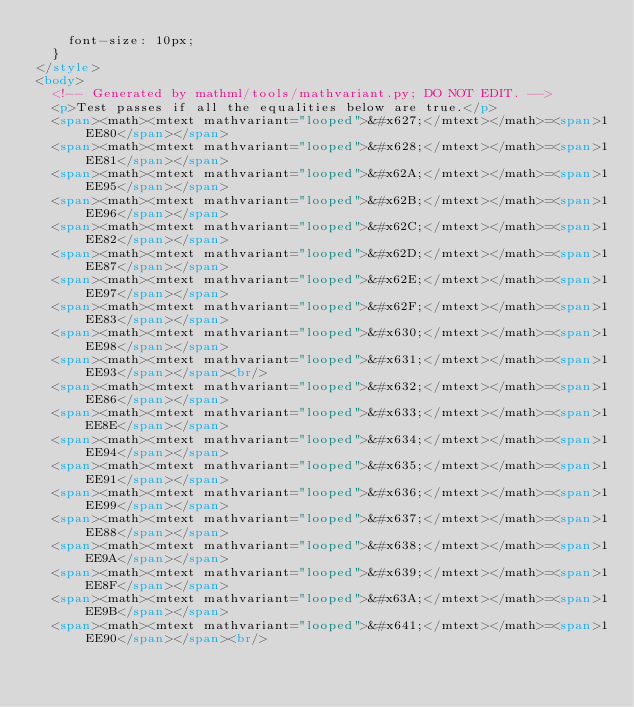Convert code to text. <code><loc_0><loc_0><loc_500><loc_500><_HTML_>    font-size: 10px;
  }
</style>
<body>
  <!-- Generated by mathml/tools/mathvariant.py; DO NOT EDIT. -->
  <p>Test passes if all the equalities below are true.</p>
  <span><math><mtext mathvariant="looped">&#x627;</mtext></math>=<span>1EE80</span></span>
  <span><math><mtext mathvariant="looped">&#x628;</mtext></math>=<span>1EE81</span></span>
  <span><math><mtext mathvariant="looped">&#x62A;</mtext></math>=<span>1EE95</span></span>
  <span><math><mtext mathvariant="looped">&#x62B;</mtext></math>=<span>1EE96</span></span>
  <span><math><mtext mathvariant="looped">&#x62C;</mtext></math>=<span>1EE82</span></span>
  <span><math><mtext mathvariant="looped">&#x62D;</mtext></math>=<span>1EE87</span></span>
  <span><math><mtext mathvariant="looped">&#x62E;</mtext></math>=<span>1EE97</span></span>
  <span><math><mtext mathvariant="looped">&#x62F;</mtext></math>=<span>1EE83</span></span>
  <span><math><mtext mathvariant="looped">&#x630;</mtext></math>=<span>1EE98</span></span>
  <span><math><mtext mathvariant="looped">&#x631;</mtext></math>=<span>1EE93</span></span><br/>
  <span><math><mtext mathvariant="looped">&#x632;</mtext></math>=<span>1EE86</span></span>
  <span><math><mtext mathvariant="looped">&#x633;</mtext></math>=<span>1EE8E</span></span>
  <span><math><mtext mathvariant="looped">&#x634;</mtext></math>=<span>1EE94</span></span>
  <span><math><mtext mathvariant="looped">&#x635;</mtext></math>=<span>1EE91</span></span>
  <span><math><mtext mathvariant="looped">&#x636;</mtext></math>=<span>1EE99</span></span>
  <span><math><mtext mathvariant="looped">&#x637;</mtext></math>=<span>1EE88</span></span>
  <span><math><mtext mathvariant="looped">&#x638;</mtext></math>=<span>1EE9A</span></span>
  <span><math><mtext mathvariant="looped">&#x639;</mtext></math>=<span>1EE8F</span></span>
  <span><math><mtext mathvariant="looped">&#x63A;</mtext></math>=<span>1EE9B</span></span>
  <span><math><mtext mathvariant="looped">&#x641;</mtext></math>=<span>1EE90</span></span><br/></code> 